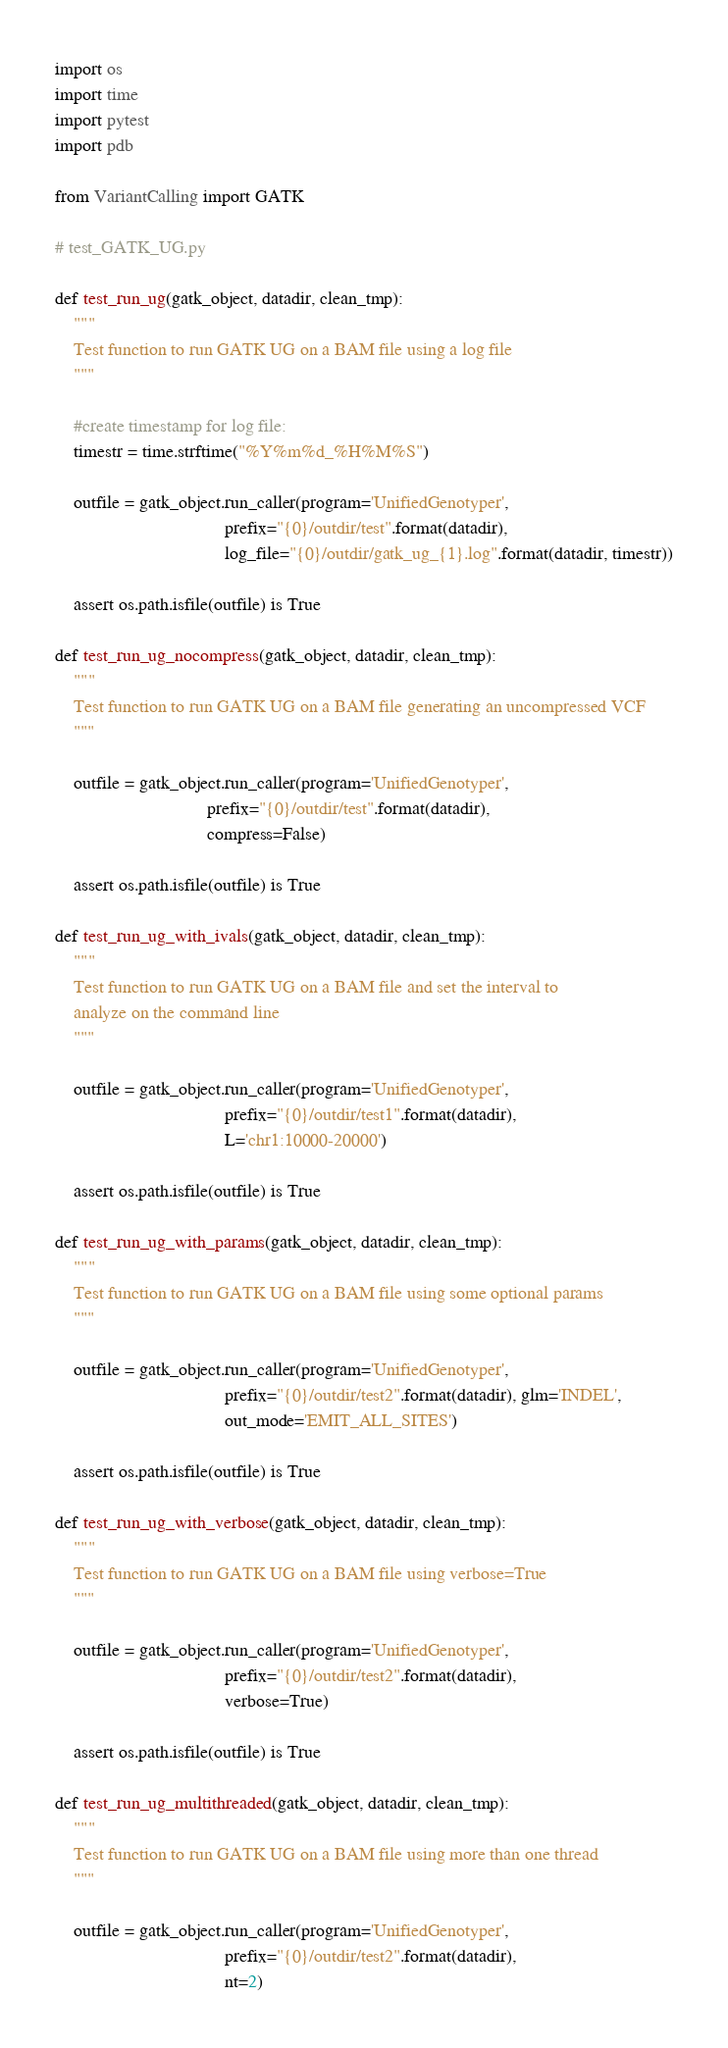Convert code to text. <code><loc_0><loc_0><loc_500><loc_500><_Python_>import os
import time
import pytest
import pdb

from VariantCalling import GATK

# test_GATK_UG.py

def test_run_ug(gatk_object, datadir, clean_tmp):
    """
    Test function to run GATK UG on a BAM file using a log file
    """

    #create timestamp for log file:
    timestr = time.strftime("%Y%m%d_%H%M%S")

    outfile = gatk_object.run_caller(program='UnifiedGenotyper',
                                     prefix="{0}/outdir/test".format(datadir),
                                     log_file="{0}/outdir/gatk_ug_{1}.log".format(datadir, timestr))

    assert os.path.isfile(outfile) is True

def test_run_ug_nocompress(gatk_object, datadir, clean_tmp):
    """
    Test function to run GATK UG on a BAM file generating an uncompressed VCF
    """

    outfile = gatk_object.run_caller(program='UnifiedGenotyper', 
                                 prefix="{0}/outdir/test".format(datadir),
                                 compress=False)

    assert os.path.isfile(outfile) is True

def test_run_ug_with_ivals(gatk_object, datadir, clean_tmp):
    """
    Test function to run GATK UG on a BAM file and set the interval to
    analyze on the command line
    """

    outfile = gatk_object.run_caller(program='UnifiedGenotyper',
                                     prefix="{0}/outdir/test1".format(datadir),
                                     L='chr1:10000-20000')

    assert os.path.isfile(outfile) is True

def test_run_ug_with_params(gatk_object, datadir, clean_tmp):
    """
    Test function to run GATK UG on a BAM file using some optional params
    """

    outfile = gatk_object.run_caller(program='UnifiedGenotyper',
                                     prefix="{0}/outdir/test2".format(datadir), glm='INDEL',
                                     out_mode='EMIT_ALL_SITES')

    assert os.path.isfile(outfile) is True

def test_run_ug_with_verbose(gatk_object, datadir, clean_tmp):
    """
    Test function to run GATK UG on a BAM file using verbose=True
    """

    outfile = gatk_object.run_caller(program='UnifiedGenotyper',
                                     prefix="{0}/outdir/test2".format(datadir),
                                     verbose=True)

    assert os.path.isfile(outfile) is True

def test_run_ug_multithreaded(gatk_object, datadir, clean_tmp):
    """
    Test function to run GATK UG on a BAM file using more than one thread
    """

    outfile = gatk_object.run_caller(program='UnifiedGenotyper',
                                     prefix="{0}/outdir/test2".format(datadir),
                                     nt=2)
</code> 